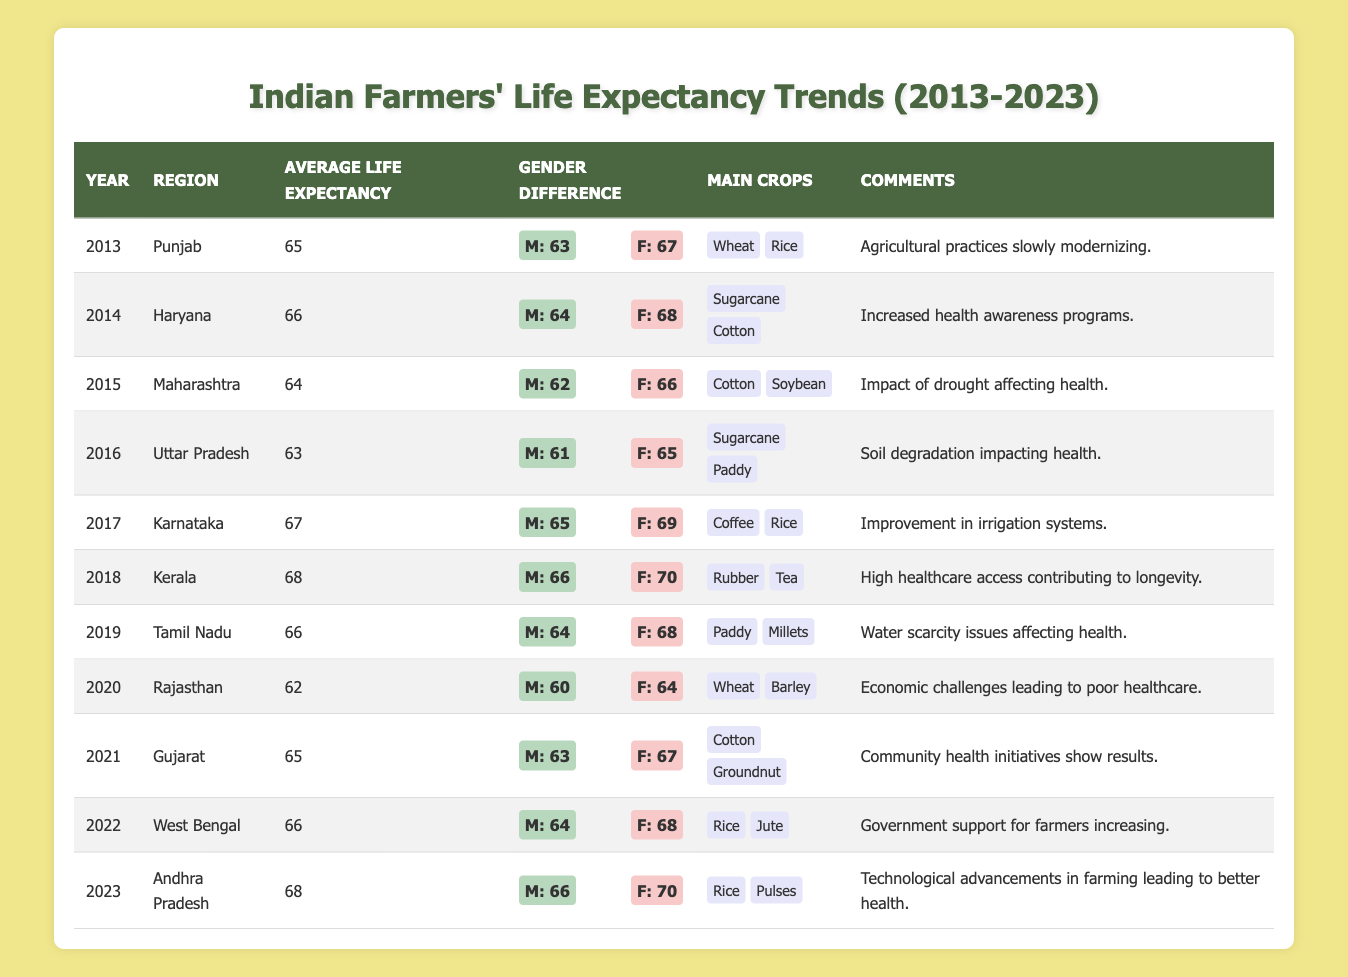What was the average life expectancy of farmers in Karnataka in 2017? Referring to the table, in the year 2017, Karnataka had an average life expectancy of 67 years.
Answer: 67 Which region had the highest average life expectancy in 2023? In 2023, Andhra Pradesh had the highest average life expectancy of 68 years, according to the table.
Answer: 68 What is the difference in life expectancy between males and females in Punjab in 2013? In 2013 in Punjab, males had a life expectancy of 63 years while females had 67 years. The difference is 67 - 63 = 4 years.
Answer: 4 Did the average life expectancy for farmers in Rajasthan increase from 2019 to 2020? In 2019, the average life expectancy in Rajasthan was 66 years, and in 2020 it decreased to 62 years, which indicates a decline.
Answer: No Calculate the average life expectancy of farmers across all regions in the year 2018. The only row for 2018 is Kerala, which had an average life expectancy of 68 years. Since there is only this one entry, the average remains 68 years.
Answer: 68 Which year saw an increase in average life expectancy compared to the previous year in Gujarat? In 2021, Gujarat had an average life expectancy of 65 years, which is an increase from 62 years in 2020. This indicates an upward trend.
Answer: Yes What was the main crop for farmers in Uttar Pradesh during the year 2016? According to the table, in 2016, the main crops for farmers in Uttar Pradesh were Sugarcane and Paddy.
Answer: Sugarcane and Paddy How many years did the average life expectancy for Tamil Nadu farmers fluctuate between 2019 and 2021? The average life expectancy in Tamil Nadu was 66 years in 2019 and was not recorded in 2020, but returned to 65 in 2021; thus, it fluctuated minimally as the difference is only 1 year from 2019 to 2021.
Answer: 1 Based on the data, did a majority of the regions show an improvement in average life expectancy from 2013 to 2022? Looking at the table, regions like Punjab, Haryana, Maharashtra, Uttar Pradesh, Rajasthan saw a decline, while Karnataka, Kerala, Tamil Nadu, Gujarat, West Bengal showed improvement, making it so that the majority did not improve.
Answer: No 